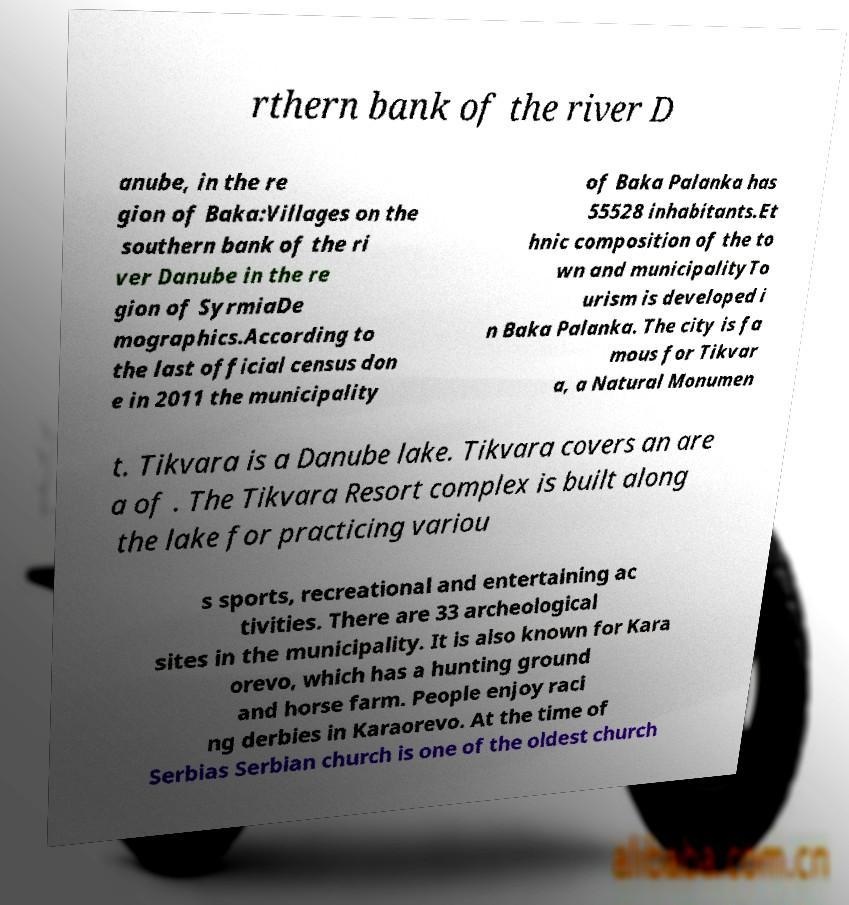Please identify and transcribe the text found in this image. rthern bank of the river D anube, in the re gion of Baka:Villages on the southern bank of the ri ver Danube in the re gion of SyrmiaDe mographics.According to the last official census don e in 2011 the municipality of Baka Palanka has 55528 inhabitants.Et hnic composition of the to wn and municipalityTo urism is developed i n Baka Palanka. The city is fa mous for Tikvar a, a Natural Monumen t. Tikvara is a Danube lake. Tikvara covers an are a of . The Tikvara Resort complex is built along the lake for practicing variou s sports, recreational and entertaining ac tivities. There are 33 archeological sites in the municipality. It is also known for Kara orevo, which has a hunting ground and horse farm. People enjoy raci ng derbies in Karaorevo. At the time of Serbias Serbian church is one of the oldest church 